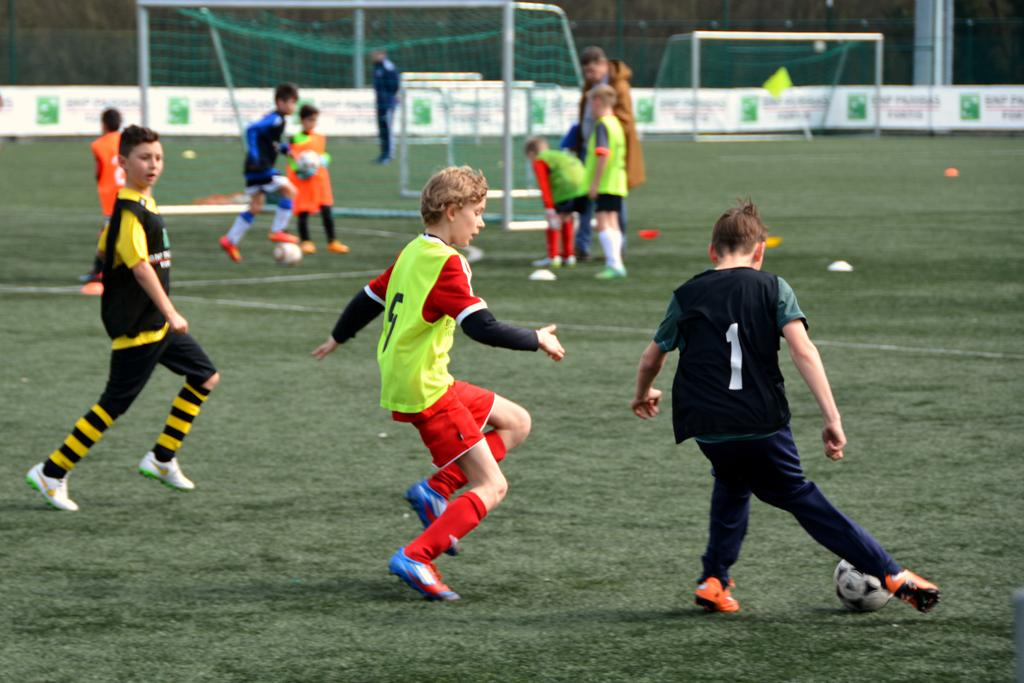How many people are in the image? There are people in the image, but the exact number is not specified. What type of clothing are the people wearing? The people are wearing sports wear. What object related to a specific sport can be seen in the image? There is a football in the image. What type of plot is being discussed by the people in the image? There is no indication in the image that the people are discussing any plot. What kind of pet can be seen accompanying the people in the image? There is no pet present in the image. 